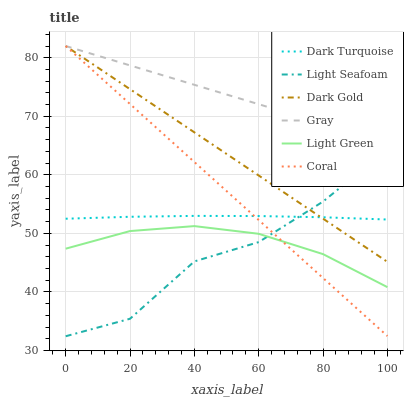Does Dark Gold have the minimum area under the curve?
Answer yes or no. No. Does Dark Gold have the maximum area under the curve?
Answer yes or no. No. Is Dark Gold the smoothest?
Answer yes or no. No. Is Dark Gold the roughest?
Answer yes or no. No. Does Dark Gold have the lowest value?
Answer yes or no. No. Does Dark Turquoise have the highest value?
Answer yes or no. No. Is Light Seafoam less than Gray?
Answer yes or no. Yes. Is Gray greater than Light Seafoam?
Answer yes or no. Yes. Does Light Seafoam intersect Gray?
Answer yes or no. No. 